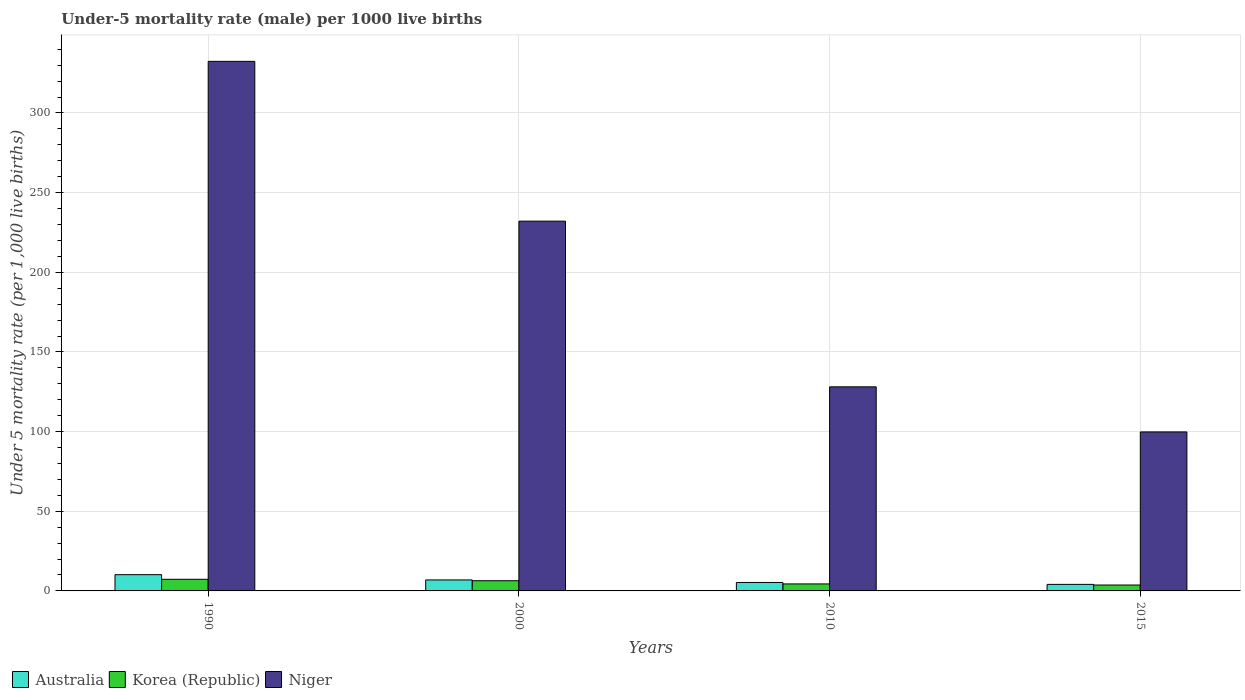How many different coloured bars are there?
Your answer should be very brief. 3. Are the number of bars on each tick of the X-axis equal?
Keep it short and to the point. Yes. How many bars are there on the 4th tick from the right?
Your answer should be very brief. 3. In how many cases, is the number of bars for a given year not equal to the number of legend labels?
Offer a very short reply. 0. What is the under-five mortality rate in Korea (Republic) in 1990?
Offer a terse response. 7.3. Across all years, what is the maximum under-five mortality rate in Korea (Republic)?
Provide a short and direct response. 7.3. In which year was the under-five mortality rate in Australia minimum?
Give a very brief answer. 2015. What is the total under-five mortality rate in Niger in the graph?
Your answer should be very brief. 792.4. What is the difference between the under-five mortality rate in Korea (Republic) in 2000 and the under-five mortality rate in Niger in 2015?
Your answer should be compact. -93.4. What is the average under-five mortality rate in Korea (Republic) per year?
Offer a terse response. 5.45. In the year 1990, what is the difference between the under-five mortality rate in Niger and under-five mortality rate in Australia?
Your response must be concise. 322.2. In how many years, is the under-five mortality rate in Australia greater than 230?
Your response must be concise. 0. What is the ratio of the under-five mortality rate in Australia in 2010 to that in 2015?
Provide a short and direct response. 1.29. Is the under-five mortality rate in Korea (Republic) in 2010 less than that in 2015?
Offer a very short reply. No. What is the difference between the highest and the second highest under-five mortality rate in Niger?
Your answer should be compact. 100.3. What is the difference between the highest and the lowest under-five mortality rate in Niger?
Ensure brevity in your answer.  232.6. In how many years, is the under-five mortality rate in Niger greater than the average under-five mortality rate in Niger taken over all years?
Offer a terse response. 2. Is the sum of the under-five mortality rate in Niger in 2000 and 2010 greater than the maximum under-five mortality rate in Korea (Republic) across all years?
Offer a terse response. Yes. What does the 2nd bar from the left in 2000 represents?
Provide a short and direct response. Korea (Republic). What does the 3rd bar from the right in 2015 represents?
Your answer should be very brief. Australia. Is it the case that in every year, the sum of the under-five mortality rate in Australia and under-five mortality rate in Korea (Republic) is greater than the under-five mortality rate in Niger?
Your answer should be very brief. No. How many bars are there?
Give a very brief answer. 12. What is the difference between two consecutive major ticks on the Y-axis?
Your answer should be compact. 50. Does the graph contain any zero values?
Provide a short and direct response. No. Does the graph contain grids?
Offer a terse response. Yes. Where does the legend appear in the graph?
Offer a very short reply. Bottom left. How are the legend labels stacked?
Provide a short and direct response. Horizontal. What is the title of the graph?
Give a very brief answer. Under-5 mortality rate (male) per 1000 live births. What is the label or title of the Y-axis?
Offer a very short reply. Under 5 mortality rate (per 1,0 live births). What is the Under 5 mortality rate (per 1,000 live births) of Korea (Republic) in 1990?
Provide a succinct answer. 7.3. What is the Under 5 mortality rate (per 1,000 live births) of Niger in 1990?
Offer a very short reply. 332.4. What is the Under 5 mortality rate (per 1,000 live births) of Australia in 2000?
Provide a succinct answer. 6.9. What is the Under 5 mortality rate (per 1,000 live births) of Korea (Republic) in 2000?
Provide a succinct answer. 6.4. What is the Under 5 mortality rate (per 1,000 live births) of Niger in 2000?
Make the answer very short. 232.1. What is the Under 5 mortality rate (per 1,000 live births) in Australia in 2010?
Provide a short and direct response. 5.3. What is the Under 5 mortality rate (per 1,000 live births) in Korea (Republic) in 2010?
Give a very brief answer. 4.4. What is the Under 5 mortality rate (per 1,000 live births) in Niger in 2010?
Provide a short and direct response. 128.1. What is the Under 5 mortality rate (per 1,000 live births) in Niger in 2015?
Ensure brevity in your answer.  99.8. Across all years, what is the maximum Under 5 mortality rate (per 1,000 live births) of Australia?
Give a very brief answer. 10.2. Across all years, what is the maximum Under 5 mortality rate (per 1,000 live births) of Niger?
Your answer should be compact. 332.4. Across all years, what is the minimum Under 5 mortality rate (per 1,000 live births) of Niger?
Keep it short and to the point. 99.8. What is the total Under 5 mortality rate (per 1,000 live births) of Korea (Republic) in the graph?
Your answer should be compact. 21.8. What is the total Under 5 mortality rate (per 1,000 live births) of Niger in the graph?
Your answer should be compact. 792.4. What is the difference between the Under 5 mortality rate (per 1,000 live births) in Niger in 1990 and that in 2000?
Keep it short and to the point. 100.3. What is the difference between the Under 5 mortality rate (per 1,000 live births) in Australia in 1990 and that in 2010?
Make the answer very short. 4.9. What is the difference between the Under 5 mortality rate (per 1,000 live births) in Korea (Republic) in 1990 and that in 2010?
Offer a very short reply. 2.9. What is the difference between the Under 5 mortality rate (per 1,000 live births) in Niger in 1990 and that in 2010?
Your answer should be compact. 204.3. What is the difference between the Under 5 mortality rate (per 1,000 live births) of Australia in 1990 and that in 2015?
Your answer should be very brief. 6.1. What is the difference between the Under 5 mortality rate (per 1,000 live births) of Niger in 1990 and that in 2015?
Provide a succinct answer. 232.6. What is the difference between the Under 5 mortality rate (per 1,000 live births) in Korea (Republic) in 2000 and that in 2010?
Your answer should be very brief. 2. What is the difference between the Under 5 mortality rate (per 1,000 live births) of Niger in 2000 and that in 2010?
Make the answer very short. 104. What is the difference between the Under 5 mortality rate (per 1,000 live births) of Australia in 2000 and that in 2015?
Provide a succinct answer. 2.8. What is the difference between the Under 5 mortality rate (per 1,000 live births) in Niger in 2000 and that in 2015?
Offer a terse response. 132.3. What is the difference between the Under 5 mortality rate (per 1,000 live births) of Australia in 2010 and that in 2015?
Keep it short and to the point. 1.2. What is the difference between the Under 5 mortality rate (per 1,000 live births) in Niger in 2010 and that in 2015?
Your answer should be compact. 28.3. What is the difference between the Under 5 mortality rate (per 1,000 live births) in Australia in 1990 and the Under 5 mortality rate (per 1,000 live births) in Niger in 2000?
Your response must be concise. -221.9. What is the difference between the Under 5 mortality rate (per 1,000 live births) of Korea (Republic) in 1990 and the Under 5 mortality rate (per 1,000 live births) of Niger in 2000?
Your answer should be very brief. -224.8. What is the difference between the Under 5 mortality rate (per 1,000 live births) of Australia in 1990 and the Under 5 mortality rate (per 1,000 live births) of Korea (Republic) in 2010?
Offer a terse response. 5.8. What is the difference between the Under 5 mortality rate (per 1,000 live births) of Australia in 1990 and the Under 5 mortality rate (per 1,000 live births) of Niger in 2010?
Make the answer very short. -117.9. What is the difference between the Under 5 mortality rate (per 1,000 live births) of Korea (Republic) in 1990 and the Under 5 mortality rate (per 1,000 live births) of Niger in 2010?
Make the answer very short. -120.8. What is the difference between the Under 5 mortality rate (per 1,000 live births) in Australia in 1990 and the Under 5 mortality rate (per 1,000 live births) in Niger in 2015?
Offer a very short reply. -89.6. What is the difference between the Under 5 mortality rate (per 1,000 live births) of Korea (Republic) in 1990 and the Under 5 mortality rate (per 1,000 live births) of Niger in 2015?
Ensure brevity in your answer.  -92.5. What is the difference between the Under 5 mortality rate (per 1,000 live births) of Australia in 2000 and the Under 5 mortality rate (per 1,000 live births) of Korea (Republic) in 2010?
Provide a succinct answer. 2.5. What is the difference between the Under 5 mortality rate (per 1,000 live births) in Australia in 2000 and the Under 5 mortality rate (per 1,000 live births) in Niger in 2010?
Offer a terse response. -121.2. What is the difference between the Under 5 mortality rate (per 1,000 live births) in Korea (Republic) in 2000 and the Under 5 mortality rate (per 1,000 live births) in Niger in 2010?
Offer a terse response. -121.7. What is the difference between the Under 5 mortality rate (per 1,000 live births) of Australia in 2000 and the Under 5 mortality rate (per 1,000 live births) of Korea (Republic) in 2015?
Give a very brief answer. 3.2. What is the difference between the Under 5 mortality rate (per 1,000 live births) of Australia in 2000 and the Under 5 mortality rate (per 1,000 live births) of Niger in 2015?
Your answer should be very brief. -92.9. What is the difference between the Under 5 mortality rate (per 1,000 live births) in Korea (Republic) in 2000 and the Under 5 mortality rate (per 1,000 live births) in Niger in 2015?
Provide a short and direct response. -93.4. What is the difference between the Under 5 mortality rate (per 1,000 live births) of Australia in 2010 and the Under 5 mortality rate (per 1,000 live births) of Korea (Republic) in 2015?
Offer a very short reply. 1.6. What is the difference between the Under 5 mortality rate (per 1,000 live births) of Australia in 2010 and the Under 5 mortality rate (per 1,000 live births) of Niger in 2015?
Your answer should be very brief. -94.5. What is the difference between the Under 5 mortality rate (per 1,000 live births) of Korea (Republic) in 2010 and the Under 5 mortality rate (per 1,000 live births) of Niger in 2015?
Provide a succinct answer. -95.4. What is the average Under 5 mortality rate (per 1,000 live births) of Australia per year?
Offer a very short reply. 6.62. What is the average Under 5 mortality rate (per 1,000 live births) in Korea (Republic) per year?
Your answer should be very brief. 5.45. What is the average Under 5 mortality rate (per 1,000 live births) of Niger per year?
Keep it short and to the point. 198.1. In the year 1990, what is the difference between the Under 5 mortality rate (per 1,000 live births) of Australia and Under 5 mortality rate (per 1,000 live births) of Korea (Republic)?
Ensure brevity in your answer.  2.9. In the year 1990, what is the difference between the Under 5 mortality rate (per 1,000 live births) in Australia and Under 5 mortality rate (per 1,000 live births) in Niger?
Provide a short and direct response. -322.2. In the year 1990, what is the difference between the Under 5 mortality rate (per 1,000 live births) in Korea (Republic) and Under 5 mortality rate (per 1,000 live births) in Niger?
Your response must be concise. -325.1. In the year 2000, what is the difference between the Under 5 mortality rate (per 1,000 live births) in Australia and Under 5 mortality rate (per 1,000 live births) in Niger?
Provide a short and direct response. -225.2. In the year 2000, what is the difference between the Under 5 mortality rate (per 1,000 live births) in Korea (Republic) and Under 5 mortality rate (per 1,000 live births) in Niger?
Your answer should be very brief. -225.7. In the year 2010, what is the difference between the Under 5 mortality rate (per 1,000 live births) in Australia and Under 5 mortality rate (per 1,000 live births) in Korea (Republic)?
Make the answer very short. 0.9. In the year 2010, what is the difference between the Under 5 mortality rate (per 1,000 live births) in Australia and Under 5 mortality rate (per 1,000 live births) in Niger?
Offer a very short reply. -122.8. In the year 2010, what is the difference between the Under 5 mortality rate (per 1,000 live births) in Korea (Republic) and Under 5 mortality rate (per 1,000 live births) in Niger?
Keep it short and to the point. -123.7. In the year 2015, what is the difference between the Under 5 mortality rate (per 1,000 live births) in Australia and Under 5 mortality rate (per 1,000 live births) in Korea (Republic)?
Provide a succinct answer. 0.4. In the year 2015, what is the difference between the Under 5 mortality rate (per 1,000 live births) of Australia and Under 5 mortality rate (per 1,000 live births) of Niger?
Your answer should be very brief. -95.7. In the year 2015, what is the difference between the Under 5 mortality rate (per 1,000 live births) in Korea (Republic) and Under 5 mortality rate (per 1,000 live births) in Niger?
Ensure brevity in your answer.  -96.1. What is the ratio of the Under 5 mortality rate (per 1,000 live births) of Australia in 1990 to that in 2000?
Make the answer very short. 1.48. What is the ratio of the Under 5 mortality rate (per 1,000 live births) in Korea (Republic) in 1990 to that in 2000?
Your answer should be very brief. 1.14. What is the ratio of the Under 5 mortality rate (per 1,000 live births) in Niger in 1990 to that in 2000?
Your response must be concise. 1.43. What is the ratio of the Under 5 mortality rate (per 1,000 live births) in Australia in 1990 to that in 2010?
Your answer should be very brief. 1.92. What is the ratio of the Under 5 mortality rate (per 1,000 live births) in Korea (Republic) in 1990 to that in 2010?
Offer a very short reply. 1.66. What is the ratio of the Under 5 mortality rate (per 1,000 live births) in Niger in 1990 to that in 2010?
Provide a succinct answer. 2.59. What is the ratio of the Under 5 mortality rate (per 1,000 live births) in Australia in 1990 to that in 2015?
Provide a short and direct response. 2.49. What is the ratio of the Under 5 mortality rate (per 1,000 live births) in Korea (Republic) in 1990 to that in 2015?
Give a very brief answer. 1.97. What is the ratio of the Under 5 mortality rate (per 1,000 live births) in Niger in 1990 to that in 2015?
Provide a short and direct response. 3.33. What is the ratio of the Under 5 mortality rate (per 1,000 live births) of Australia in 2000 to that in 2010?
Offer a very short reply. 1.3. What is the ratio of the Under 5 mortality rate (per 1,000 live births) in Korea (Republic) in 2000 to that in 2010?
Offer a very short reply. 1.45. What is the ratio of the Under 5 mortality rate (per 1,000 live births) of Niger in 2000 to that in 2010?
Ensure brevity in your answer.  1.81. What is the ratio of the Under 5 mortality rate (per 1,000 live births) in Australia in 2000 to that in 2015?
Your response must be concise. 1.68. What is the ratio of the Under 5 mortality rate (per 1,000 live births) of Korea (Republic) in 2000 to that in 2015?
Give a very brief answer. 1.73. What is the ratio of the Under 5 mortality rate (per 1,000 live births) of Niger in 2000 to that in 2015?
Provide a succinct answer. 2.33. What is the ratio of the Under 5 mortality rate (per 1,000 live births) of Australia in 2010 to that in 2015?
Give a very brief answer. 1.29. What is the ratio of the Under 5 mortality rate (per 1,000 live births) in Korea (Republic) in 2010 to that in 2015?
Your answer should be very brief. 1.19. What is the ratio of the Under 5 mortality rate (per 1,000 live births) of Niger in 2010 to that in 2015?
Make the answer very short. 1.28. What is the difference between the highest and the second highest Under 5 mortality rate (per 1,000 live births) of Australia?
Make the answer very short. 3.3. What is the difference between the highest and the second highest Under 5 mortality rate (per 1,000 live births) in Niger?
Offer a very short reply. 100.3. What is the difference between the highest and the lowest Under 5 mortality rate (per 1,000 live births) in Niger?
Keep it short and to the point. 232.6. 